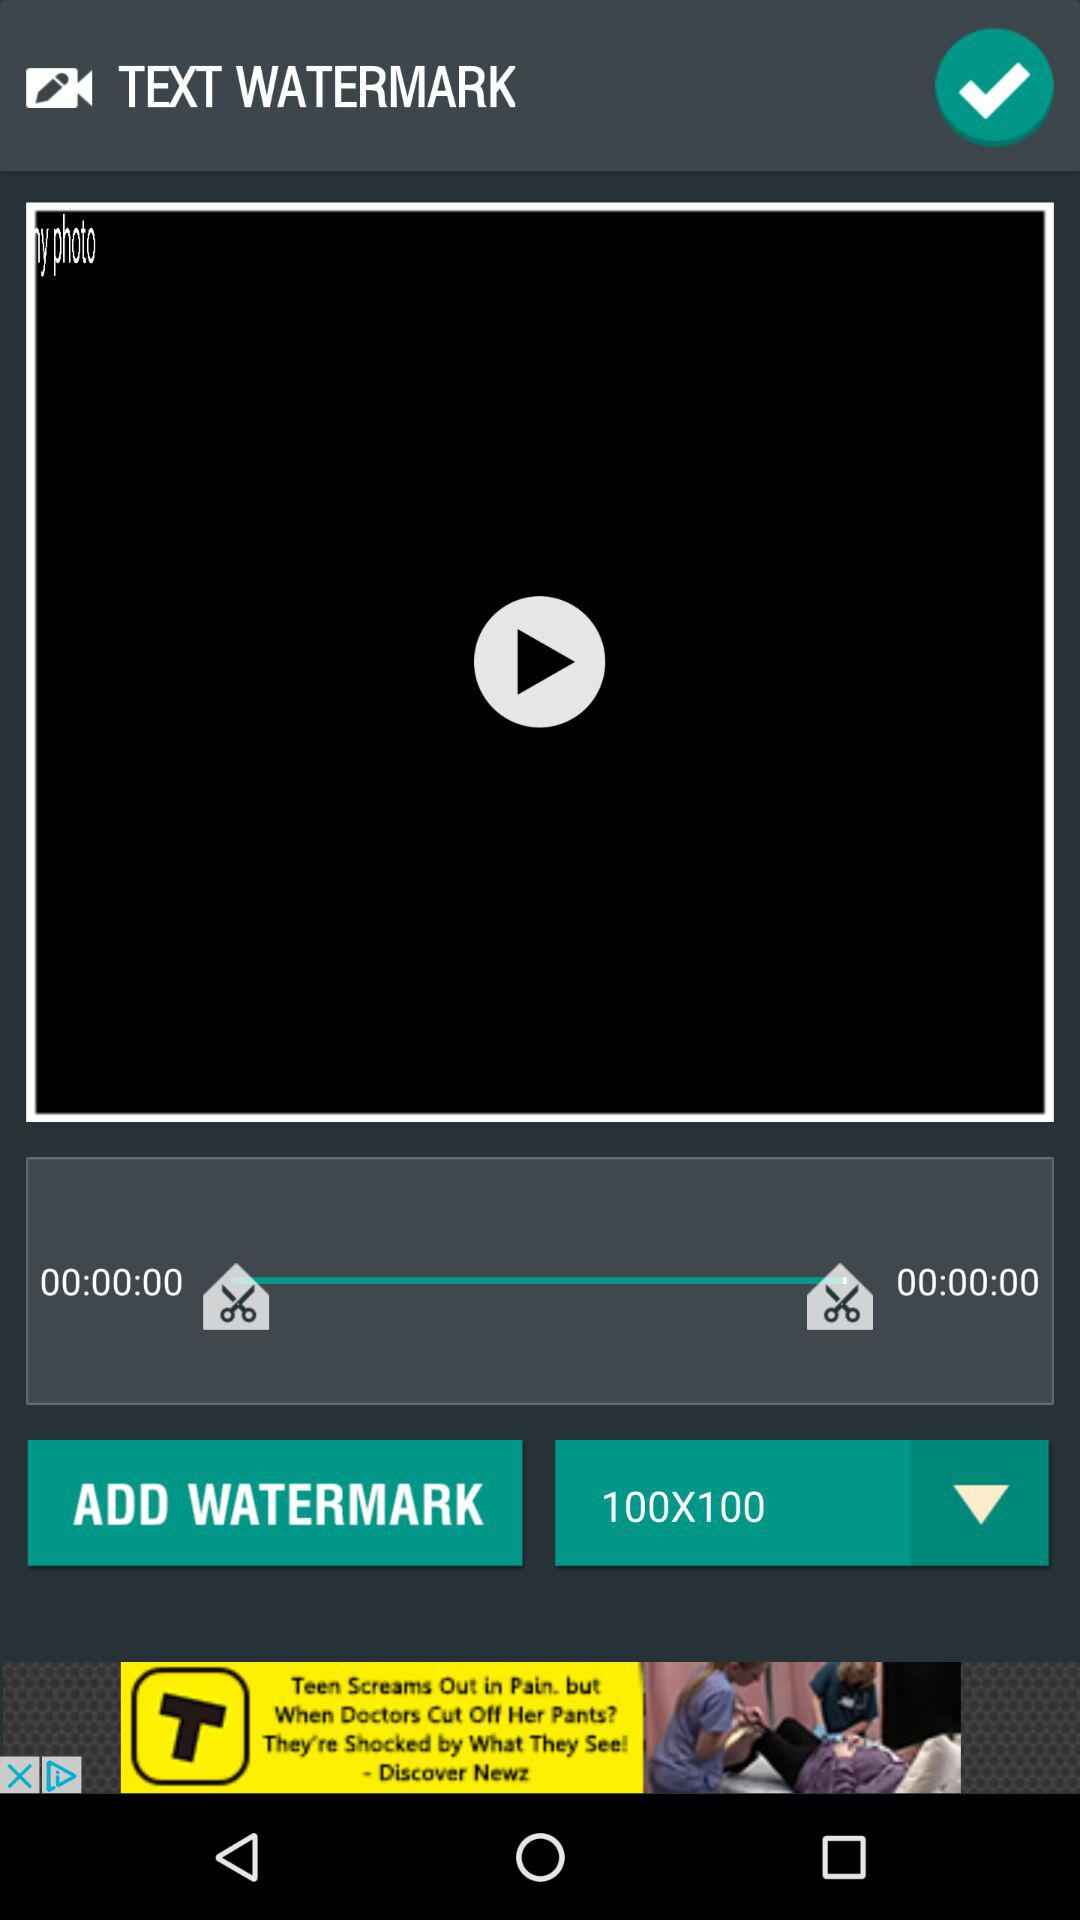What is the duration of audio?
When the provided information is insufficient, respond with <no answer>. <no answer> 